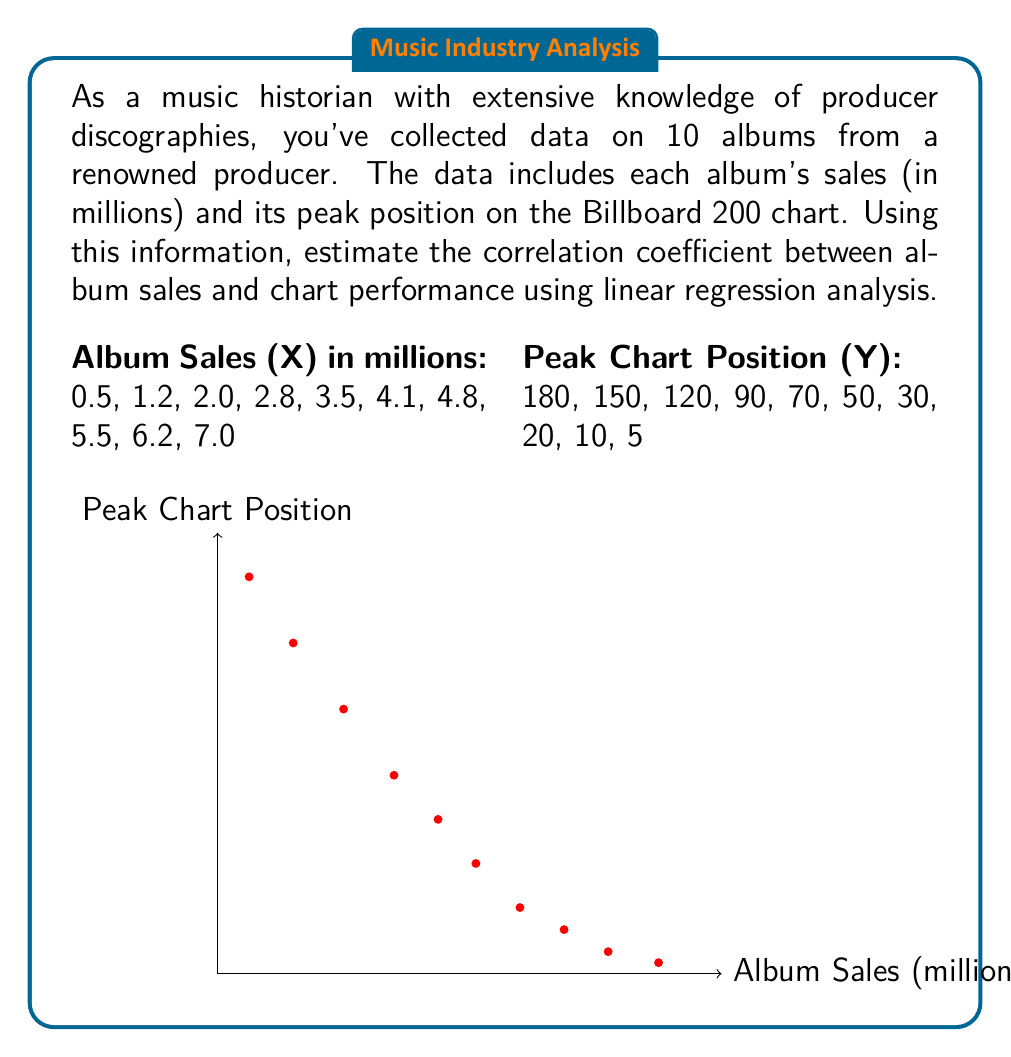Teach me how to tackle this problem. To estimate the correlation coefficient using linear regression analysis, we'll follow these steps:

1) Calculate the means of X and Y:
   $\bar{X} = \frac{\sum X_i}{n} = \frac{37.6}{10} = 3.76$
   $\bar{Y} = \frac{\sum Y_i}{n} = \frac{725}{10} = 72.5$

2) Calculate the variances of X and Y:
   $S_X^2 = \frac{\sum (X_i - \bar{X})^2}{n-1}$
   $S_Y^2 = \frac{\sum (Y_i - \bar{Y})^2}{n-1}$

3) Calculate the covariance of X and Y:
   $S_{XY} = \frac{\sum (X_i - \bar{X})(Y_i - \bar{Y})}{n-1}$

4) The correlation coefficient is given by:
   $r = \frac{S_{XY}}{\sqrt{S_X^2 S_Y^2}}$

Calculating step by step:

$S_X^2 = \frac{53.324}{9} = 5.925$
$S_Y^2 = \frac{47,712.5}{9} = 5,301.39$
$S_{XY} = \frac{-1,248.7}{9} = -138.74$

Therefore,
$r = \frac{-138.74}{\sqrt{5.925 \times 5,301.39}} = -0.9829$

The correlation coefficient is approximately -0.9829, indicating a very strong negative correlation between album sales and peak chart position. This makes sense because lower numbers in chart positions indicate better performance (e.g., #1 is the top of the chart).
Answer: $r \approx -0.9829$ 